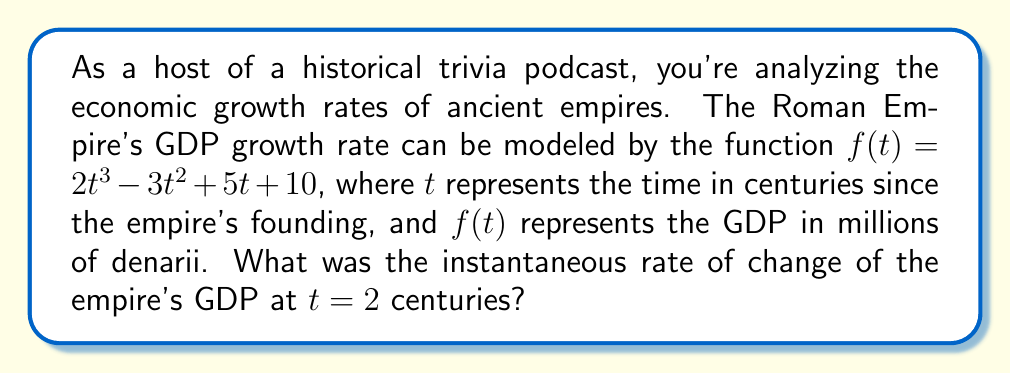Solve this math problem. To find the instantaneous rate of change at $t = 2$, we need to calculate the derivative of the function $f(t)$ and then evaluate it at $t = 2$.

Step 1: Find the derivative of $f(t)$.
$f(t) = 2t^3 - 3t^2 + 5t + 10$
$f'(t) = 6t^2 - 6t + 5$

Step 2: Evaluate $f'(t)$ at $t = 2$.
$f'(2) = 6(2)^2 - 6(2) + 5$
$f'(2) = 6(4) - 12 + 5$
$f'(2) = 24 - 12 + 5$
$f'(2) = 17$

Therefore, the instantaneous rate of change of the Roman Empire's GDP at $t = 2$ centuries was 17 million denarii per century.
Answer: 17 million denarii per century 